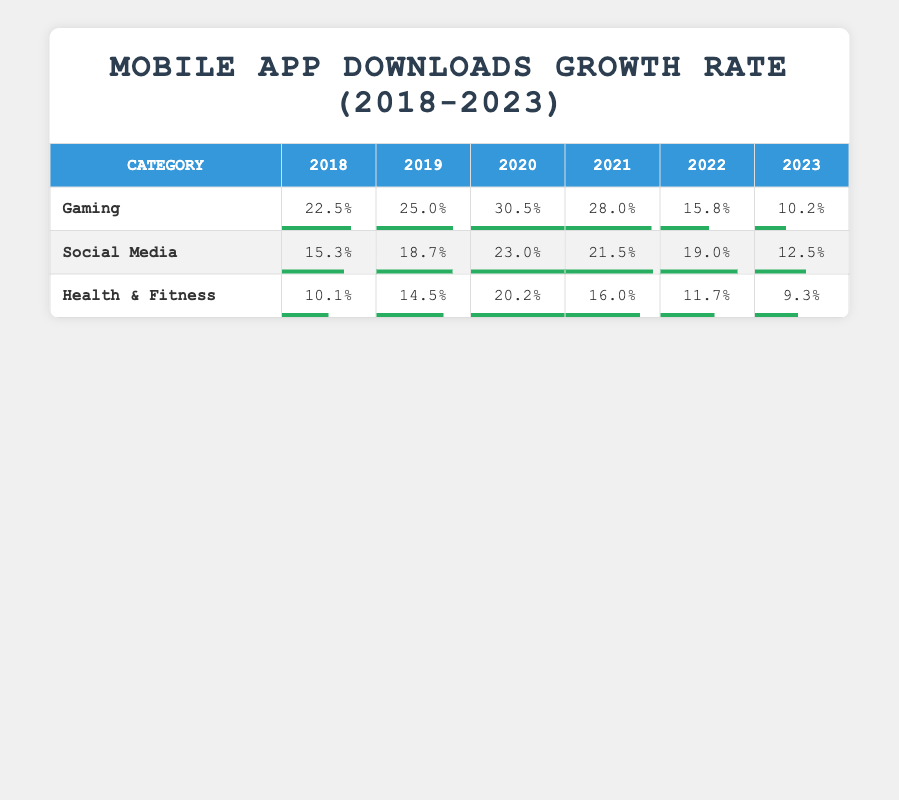What was the growth rate of Gaming in 2020? The table shows that in 2020, the growth rate for the Gaming category is 30.5%.
Answer: 30.5% Which category had the highest growth rate in 2019? In 2019, the Gaming category had the highest growth rate at 25.0%, compared to 18.7% for Social Media and 14.5% for Health & Fitness.
Answer: Gaming What was the average growth rate for Social Media from 2018 to 2023? To calculate the average, sum the growth rates for Social Media: 15.3 + 18.7 + 23.0 + 21.5 + 19.0 + 12.5 = 110.0. There are 6 years, so the average is 110.0 / 6 = 18.33.
Answer: 18.33 Did the growth rate of Health & Fitness increase from 2018 to 2020? In 2018, the growth rate was 10.1%, and in 2019 it was 14.5%, which shows an increase. In 2020, the growth rate reached 20.2%, indicating a continuous rise.
Answer: Yes What was the difference in growth rate for Gaming between 2019 and 2023? The growth rate for Gaming in 2019 was 25.0%, and in 2023 it dropped to 10.2%. The difference is 25.0 - 10.2 = 14.8.
Answer: 14.8 Which year saw the lowest growth rate for Health & Fitness, and what was that rate? The lowest growth rate for Health & Fitness was in 2023 with a rate of 9.3%, while in previous years it was higher: 10.1% in 2018, 14.5% in 2019, 20.2% in 2020, and 16.0% in 2021, and 11.7% in 2022.
Answer: 2023, 9.3% How has the growth rate of Gaming changed from 2020 to 2022? In 2020, the growth rate was 30.5%, which decreased to 15.8% in 2022. This shows a decline over the two years.
Answer: Decreased In which year did Social Media achieve its peak growth rate, and what was that rate? The peak growth rate for Social Media was in 2020 at 23.0%, which was higher than rates for all other years.
Answer: 2020, 23.0% 